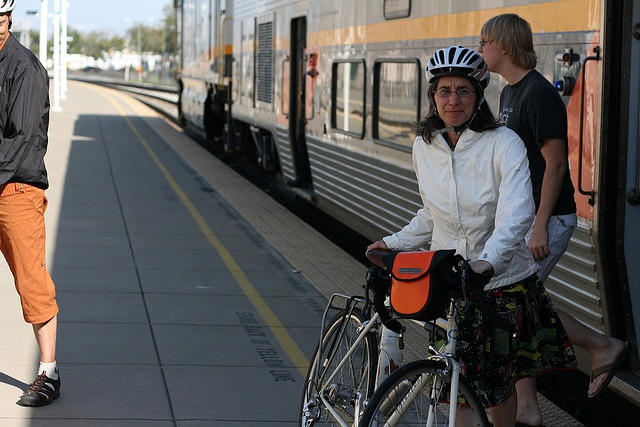Describe the objects in this image and their specific colors. I can see train in white, black, darkgray, gray, and tan tones, people in white, black, darkgray, and gray tones, bicycle in white, black, gray, darkgray, and brown tones, people in white, gray, salmon, and black tones, and people in white, black, gray, maroon, and brown tones in this image. 